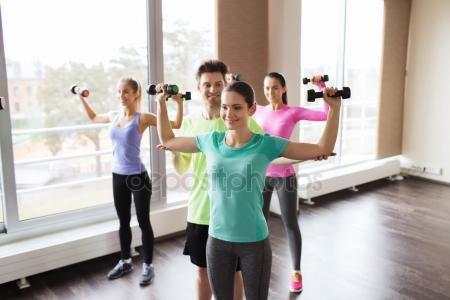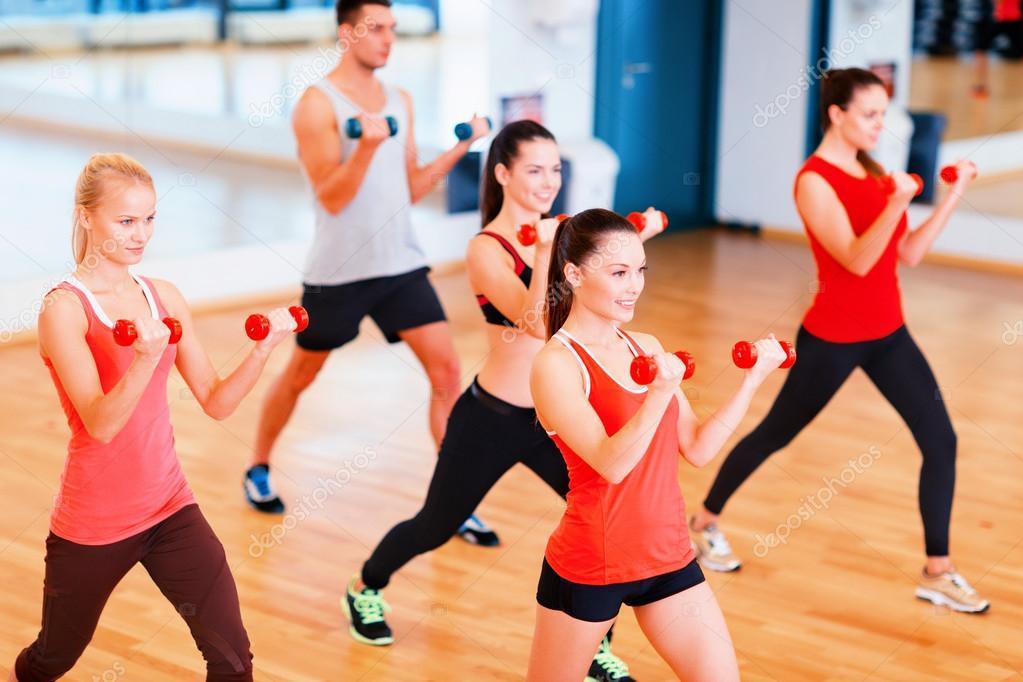The first image is the image on the left, the second image is the image on the right. Analyze the images presented: Is the assertion "There are nine people working out." valid? Answer yes or no. Yes. The first image is the image on the left, the second image is the image on the right. Analyze the images presented: Is the assertion "Nine or fewer humans are visible." valid? Answer yes or no. Yes. 